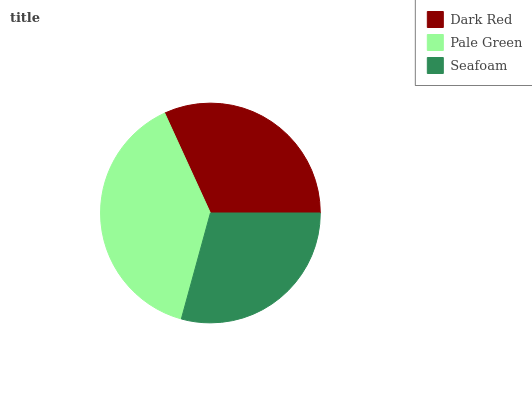Is Seafoam the minimum?
Answer yes or no. Yes. Is Pale Green the maximum?
Answer yes or no. Yes. Is Pale Green the minimum?
Answer yes or no. No. Is Seafoam the maximum?
Answer yes or no. No. Is Pale Green greater than Seafoam?
Answer yes or no. Yes. Is Seafoam less than Pale Green?
Answer yes or no. Yes. Is Seafoam greater than Pale Green?
Answer yes or no. No. Is Pale Green less than Seafoam?
Answer yes or no. No. Is Dark Red the high median?
Answer yes or no. Yes. Is Dark Red the low median?
Answer yes or no. Yes. Is Seafoam the high median?
Answer yes or no. No. Is Pale Green the low median?
Answer yes or no. No. 